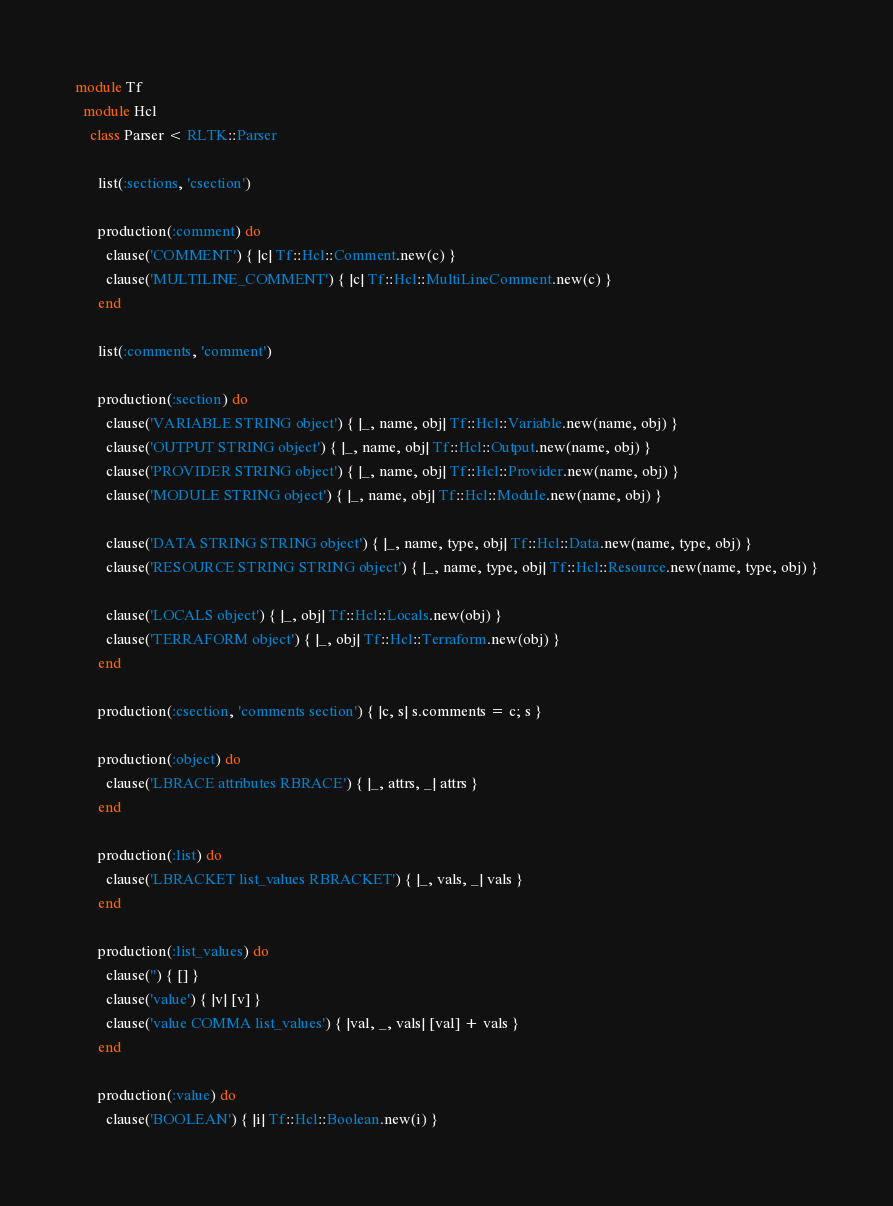Convert code to text. <code><loc_0><loc_0><loc_500><loc_500><_Ruby_>module Tf
  module Hcl
    class Parser < RLTK::Parser

      list(:sections, 'csection')

      production(:comment) do
        clause('COMMENT') { |c| Tf::Hcl::Comment.new(c) }
        clause('MULTILINE_COMMENT') { |c| Tf::Hcl::MultiLineComment.new(c) }
      end

      list(:comments, 'comment')

      production(:section) do
        clause('VARIABLE STRING object') { |_, name, obj| Tf::Hcl::Variable.new(name, obj) }
        clause('OUTPUT STRING object') { |_, name, obj| Tf::Hcl::Output.new(name, obj) }
        clause('PROVIDER STRING object') { |_, name, obj| Tf::Hcl::Provider.new(name, obj) }
        clause('MODULE STRING object') { |_, name, obj| Tf::Hcl::Module.new(name, obj) }

        clause('DATA STRING STRING object') { |_, name, type, obj| Tf::Hcl::Data.new(name, type, obj) }
        clause('RESOURCE STRING STRING object') { |_, name, type, obj| Tf::Hcl::Resource.new(name, type, obj) }

        clause('LOCALS object') { |_, obj| Tf::Hcl::Locals.new(obj) }
        clause('TERRAFORM object') { |_, obj| Tf::Hcl::Terraform.new(obj) }
      end

      production(:csection, 'comments section') { |c, s| s.comments = c; s }

      production(:object) do
        clause('LBRACE attributes RBRACE') { |_, attrs, _| attrs }
      end

      production(:list) do
        clause('LBRACKET list_values RBRACKET') { |_, vals, _| vals }
      end

      production(:list_values) do
        clause('') { [] }
        clause('value') { |v| [v] }
        clause('value COMMA list_values') { |val, _, vals| [val] + vals }
      end

      production(:value) do
        clause('BOOLEAN') { |i| Tf::Hcl::Boolean.new(i) }</code> 